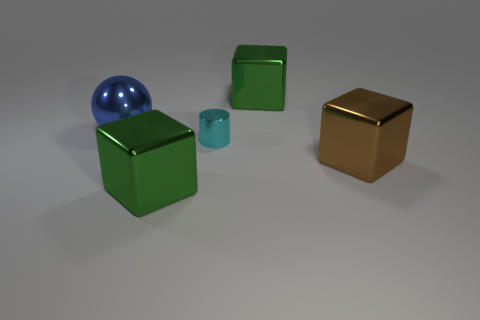Is there any other thing that has the same size as the cyan shiny object?
Provide a succinct answer. No. Are there more yellow rubber cylinders than green things?
Your answer should be very brief. No. There is a shiny thing on the right side of the large green thing that is on the right side of the big thing that is in front of the large brown block; what shape is it?
Ensure brevity in your answer.  Cube. Do the green object behind the metallic cylinder and the large brown thing to the right of the big metallic ball have the same material?
Your answer should be very brief. Yes. There is a large brown thing that is made of the same material as the blue object; what is its shape?
Give a very brief answer. Cube. Is there anything else that has the same color as the tiny cylinder?
Make the answer very short. No. What number of big brown objects are there?
Keep it short and to the point. 1. What material is the green block in front of the large metallic block that is behind the small cylinder made of?
Make the answer very short. Metal. What color is the metal cube on the right side of the green metallic block that is behind the cylinder that is in front of the large blue metallic thing?
Provide a succinct answer. Brown. Do the shiny cylinder and the big sphere have the same color?
Make the answer very short. No. 